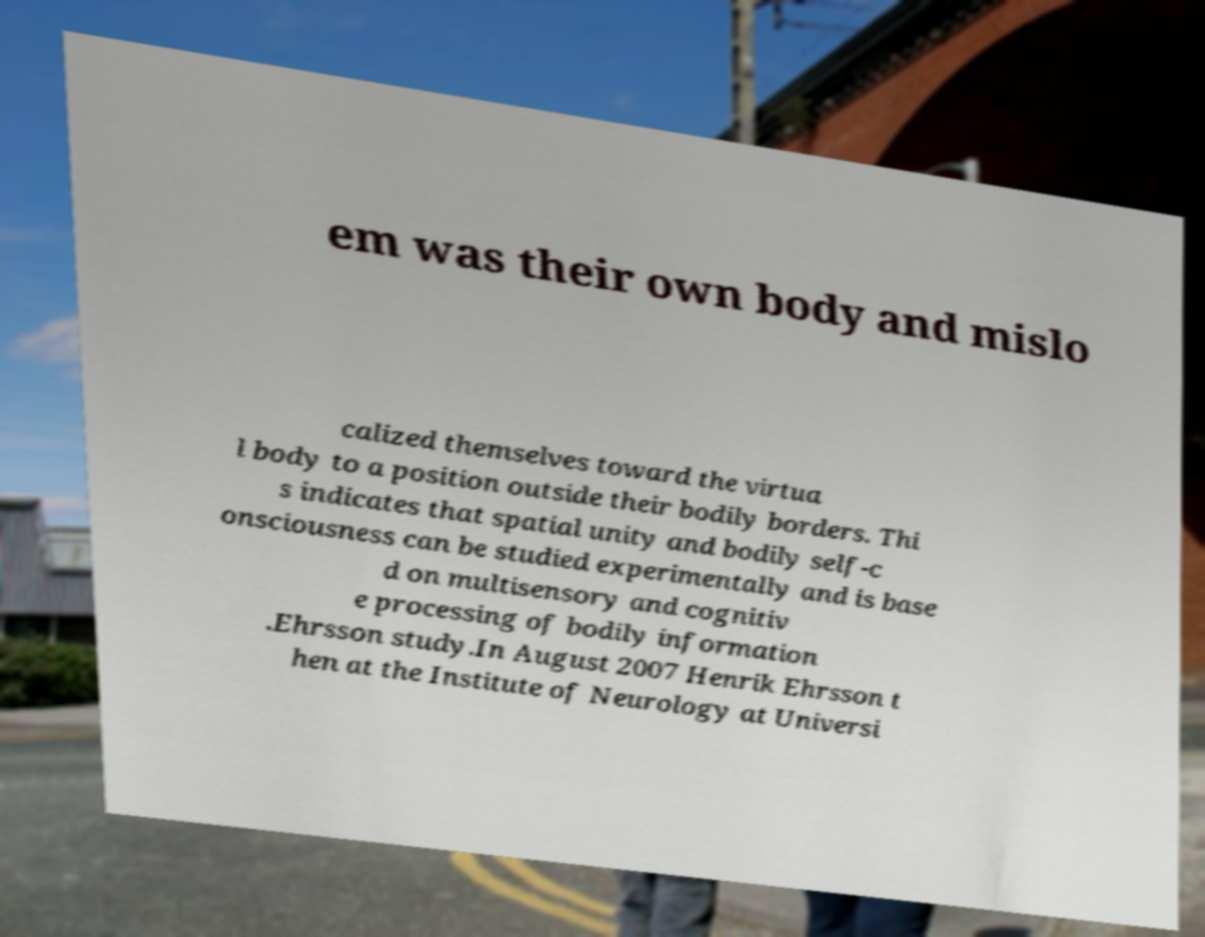There's text embedded in this image that I need extracted. Can you transcribe it verbatim? em was their own body and mislo calized themselves toward the virtua l body to a position outside their bodily borders. Thi s indicates that spatial unity and bodily self-c onsciousness can be studied experimentally and is base d on multisensory and cognitiv e processing of bodily information .Ehrsson study.In August 2007 Henrik Ehrsson t hen at the Institute of Neurology at Universi 